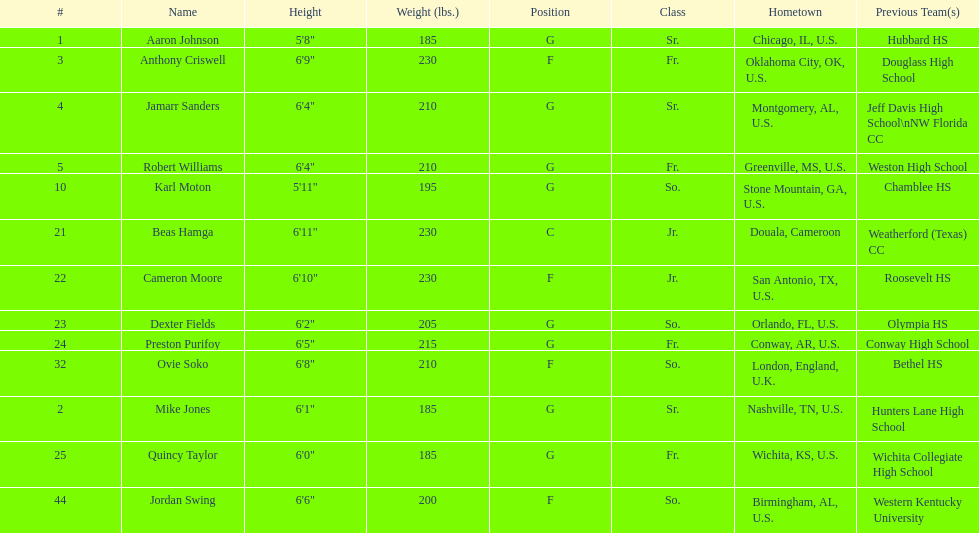What is the count of juniors in the team? 2. 